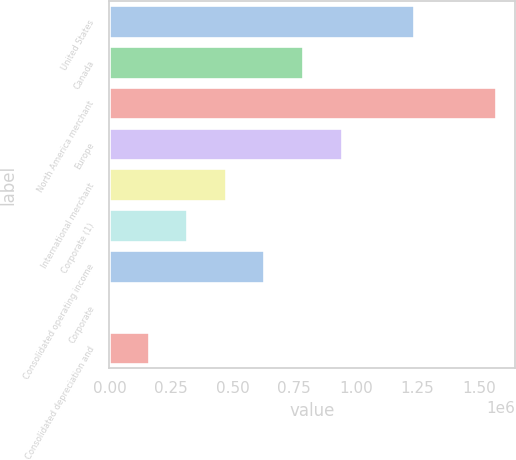<chart> <loc_0><loc_0><loc_500><loc_500><bar_chart><fcel>United States<fcel>Canada<fcel>North America merchant<fcel>Europe<fcel>International merchant<fcel>Corporate (1)<fcel>Consolidated operating income<fcel>Corporate<fcel>Consolidated depreciation and<nl><fcel>1.23482e+06<fcel>785205<fcel>1.56725e+06<fcel>941614<fcel>472386<fcel>315977<fcel>628796<fcel>3158<fcel>159567<nl></chart> 